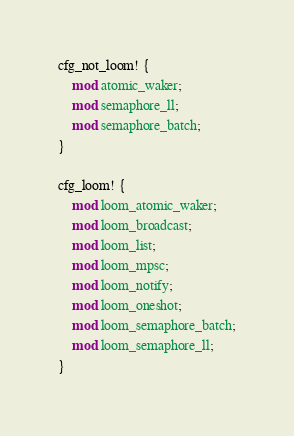Convert code to text. <code><loc_0><loc_0><loc_500><loc_500><_Rust_>cfg_not_loom! {
    mod atomic_waker;
    mod semaphore_ll;
    mod semaphore_batch;
}

cfg_loom! {
    mod loom_atomic_waker;
    mod loom_broadcast;
    mod loom_list;
    mod loom_mpsc;
    mod loom_notify;
    mod loom_oneshot;
    mod loom_semaphore_batch;
    mod loom_semaphore_ll;
}
</code> 